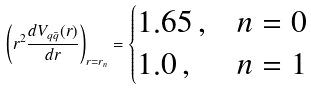Convert formula to latex. <formula><loc_0><loc_0><loc_500><loc_500>\left ( r ^ { 2 } \frac { d V _ { q \bar { q } } ( r ) } { d r } \right ) _ { r = r _ { n } } = \begin{cases} 1 . 6 5 \, , & n = 0 \\ 1 . 0 \, , & n = 1 \end{cases}</formula> 